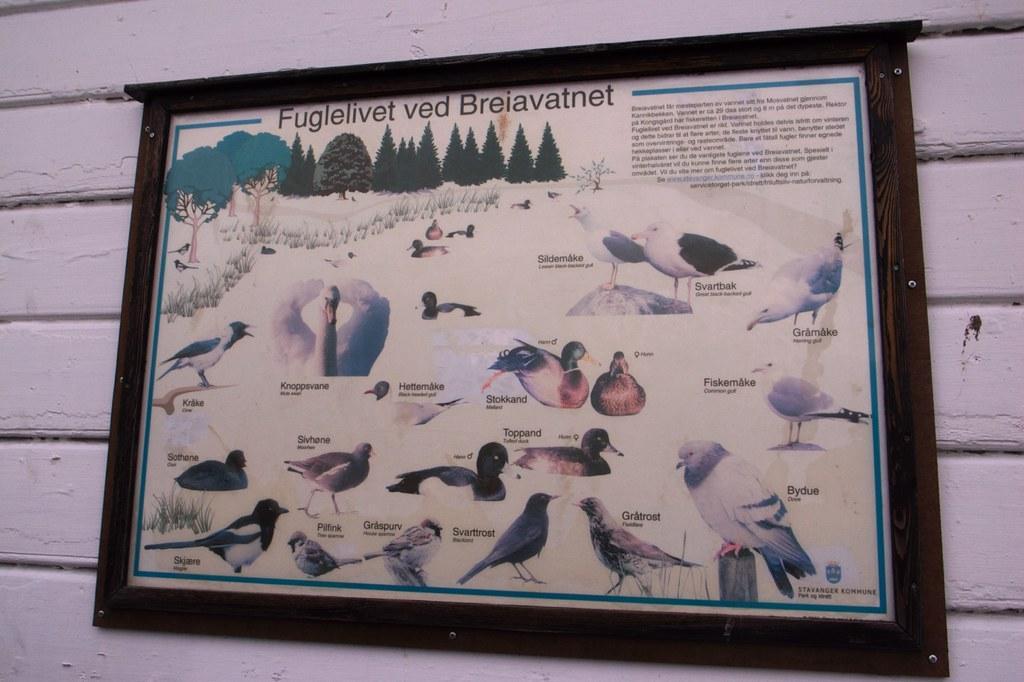Please provide a concise description of this image. In this image we can see a frame placed on the wall. 